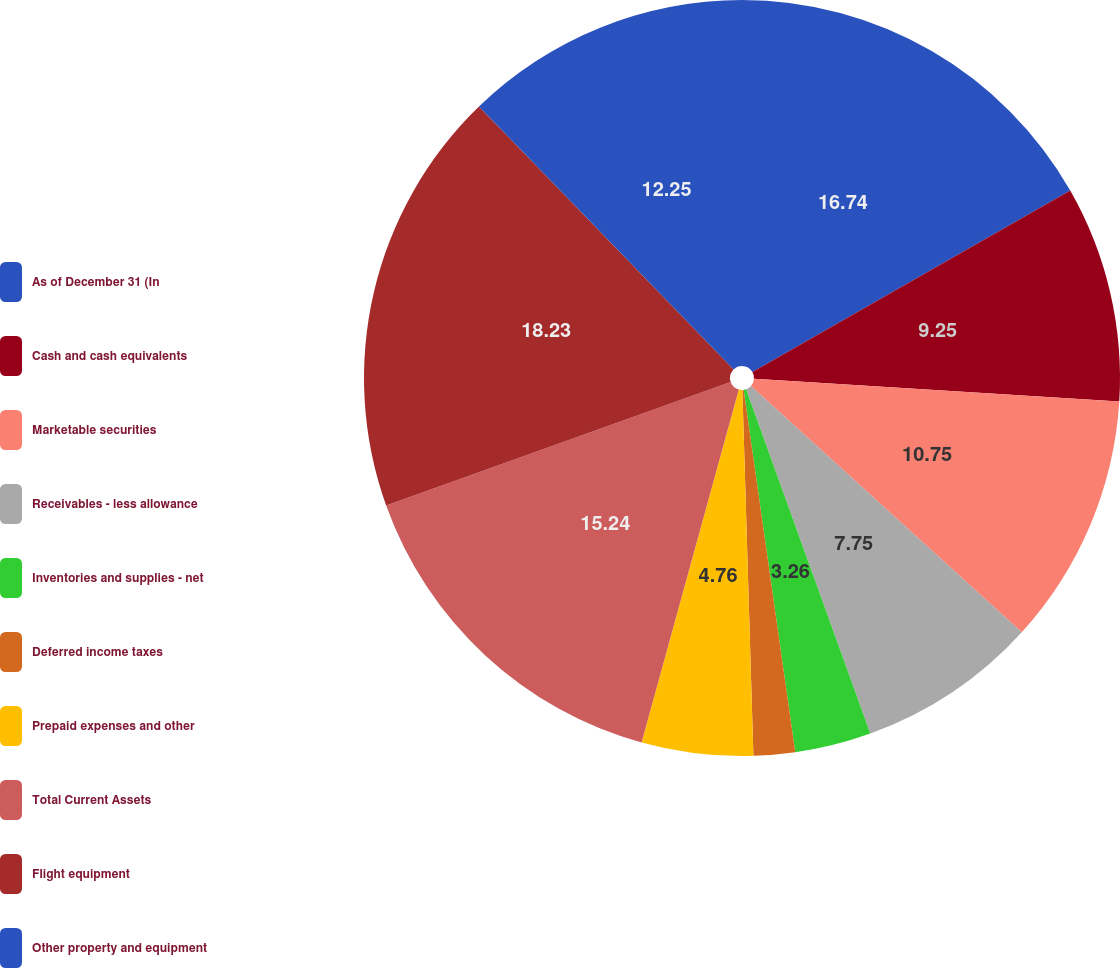Convert chart to OTSL. <chart><loc_0><loc_0><loc_500><loc_500><pie_chart><fcel>As of December 31 (In<fcel>Cash and cash equivalents<fcel>Marketable securities<fcel>Receivables - less allowance<fcel>Inventories and supplies - net<fcel>Deferred income taxes<fcel>Prepaid expenses and other<fcel>Total Current Assets<fcel>Flight equipment<fcel>Other property and equipment<nl><fcel>16.74%<fcel>9.25%<fcel>10.75%<fcel>7.75%<fcel>3.26%<fcel>1.77%<fcel>4.76%<fcel>15.24%<fcel>18.23%<fcel>12.25%<nl></chart> 